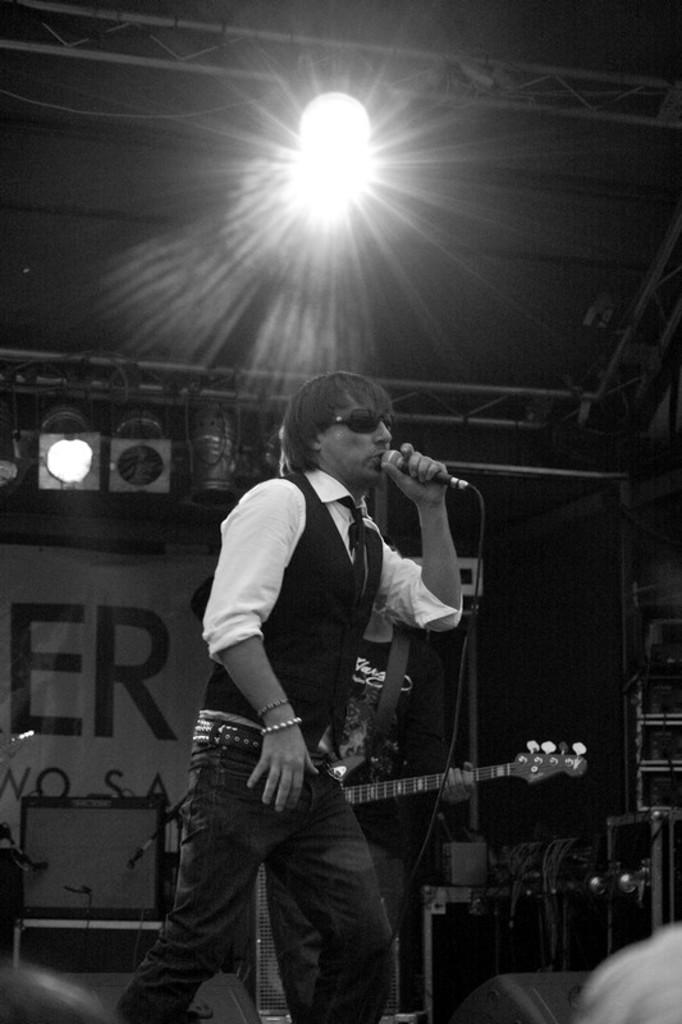What is the man in the image doing? The man is singing in the image. What is the man holding while singing? The man is holding a microphone. Can you describe the person behind the singer? The man behind the singer is holding a guitar. What can be seen illuminating the scene from above? A light is focused on them from the top. What type of trade is the man in the image participating in? There is no indication of any trade in the image; it simply shows a man singing with a guitarist behind him. Can you tell me how many hearts are visible in the image? There are no hearts visible in the image. 